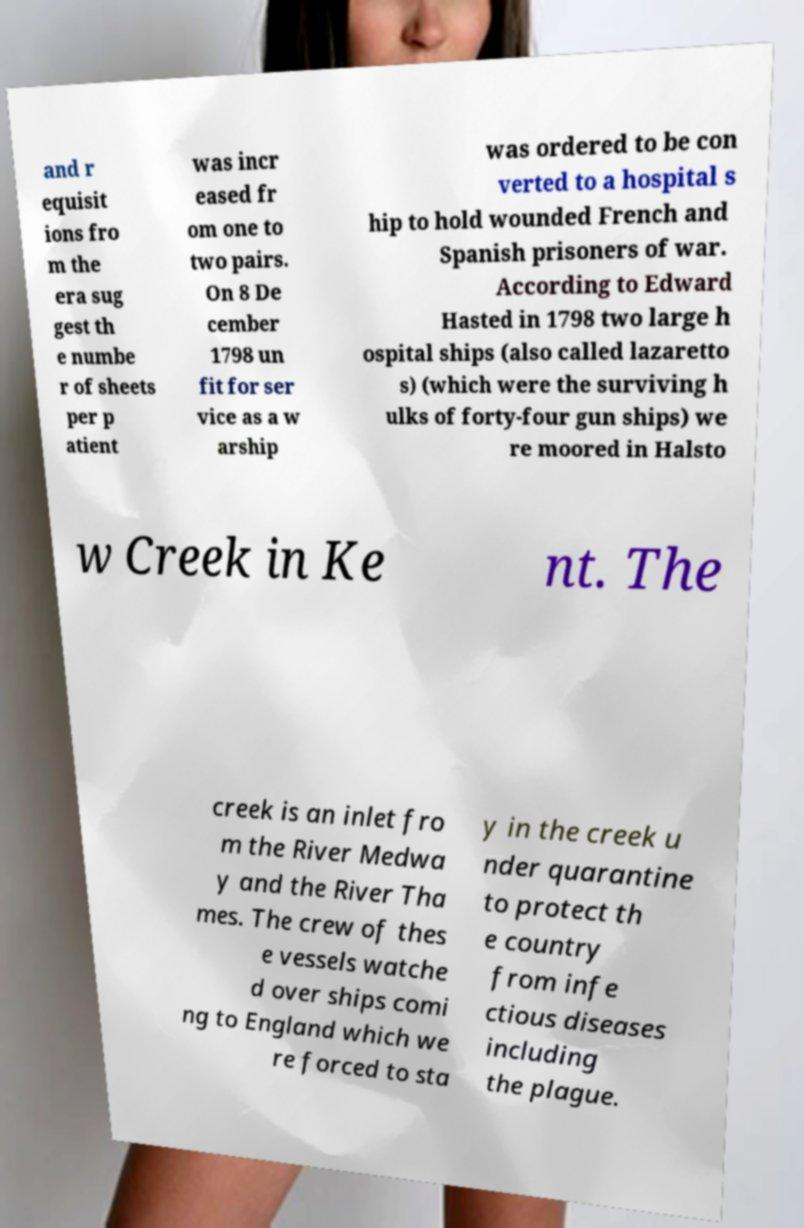What messages or text are displayed in this image? I need them in a readable, typed format. and r equisit ions fro m the era sug gest th e numbe r of sheets per p atient was incr eased fr om one to two pairs. On 8 De cember 1798 un fit for ser vice as a w arship was ordered to be con verted to a hospital s hip to hold wounded French and Spanish prisoners of war. According to Edward Hasted in 1798 two large h ospital ships (also called lazaretto s) (which were the surviving h ulks of forty-four gun ships) we re moored in Halsto w Creek in Ke nt. The creek is an inlet fro m the River Medwa y and the River Tha mes. The crew of thes e vessels watche d over ships comi ng to England which we re forced to sta y in the creek u nder quarantine to protect th e country from infe ctious diseases including the plague. 